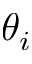<formula> <loc_0><loc_0><loc_500><loc_500>\theta _ { i }</formula> 